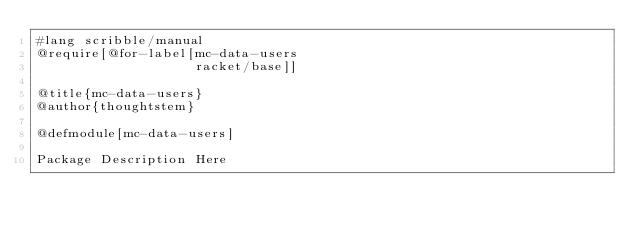Convert code to text. <code><loc_0><loc_0><loc_500><loc_500><_Racket_>#lang scribble/manual
@require[@for-label[mc-data-users
                    racket/base]]

@title{mc-data-users}
@author{thoughtstem}

@defmodule[mc-data-users]

Package Description Here
</code> 